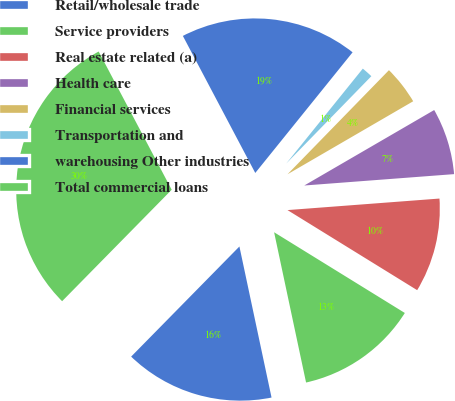<chart> <loc_0><loc_0><loc_500><loc_500><pie_chart><fcel>Retail/wholesale trade<fcel>Service providers<fcel>Real estate related (a)<fcel>Health care<fcel>Financial services<fcel>Transportation and<fcel>warehousing Other industries<fcel>Total commercial loans<nl><fcel>15.7%<fcel>12.86%<fcel>10.01%<fcel>7.17%<fcel>4.33%<fcel>1.49%<fcel>18.54%<fcel>29.9%<nl></chart> 